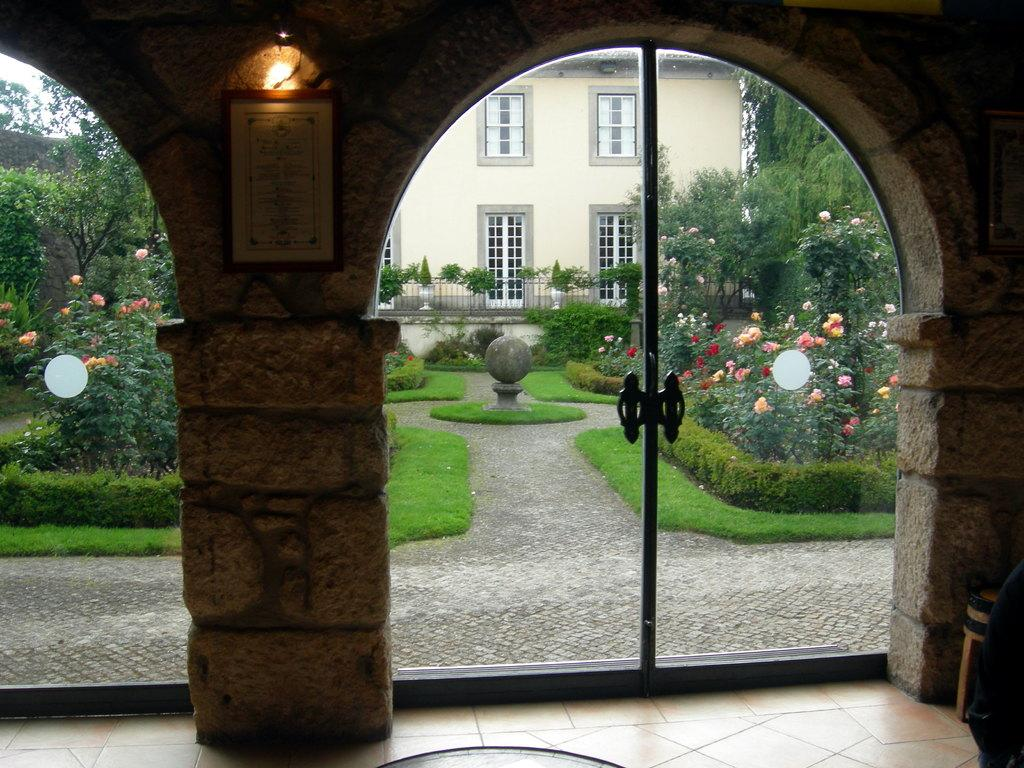How many pillars can be seen in the image? There are two pillars in the image. What type of vegetation is present in the image? There are green color plants and trees in the image. What type of structure is visible in the image? There is a house in the image. How many sacks are being carried by the ants in the image? There are no ants or sacks present in the image. What type of plot is the house located on in the image? The provided facts do not mention any plot or land associated with the house, so it cannot be determined from the image. 